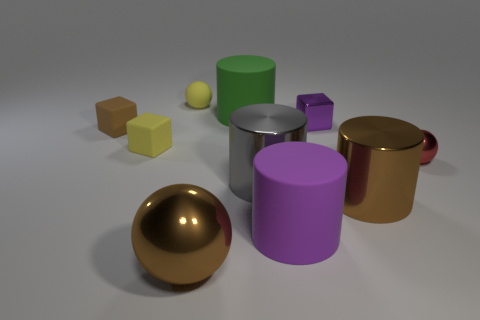Subtract all brown metal cylinders. How many cylinders are left? 3 Subtract 1 balls. How many balls are left? 2 Subtract all green cylinders. How many cylinders are left? 3 Subtract all cylinders. How many objects are left? 6 Add 2 matte cylinders. How many matte cylinders exist? 4 Subtract 1 green cylinders. How many objects are left? 9 Subtract all cyan spheres. Subtract all blue cylinders. How many spheres are left? 3 Subtract all purple matte balls. Subtract all small rubber blocks. How many objects are left? 8 Add 8 big rubber things. How many big rubber things are left? 10 